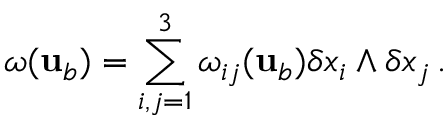Convert formula to latex. <formula><loc_0><loc_0><loc_500><loc_500>\omega ( { u } _ { b } ) = \sum _ { i , j = 1 } ^ { 3 } \omega _ { i j } ( { u } _ { b } ) \delta x _ { i } \wedge \delta x _ { j } \, .</formula> 